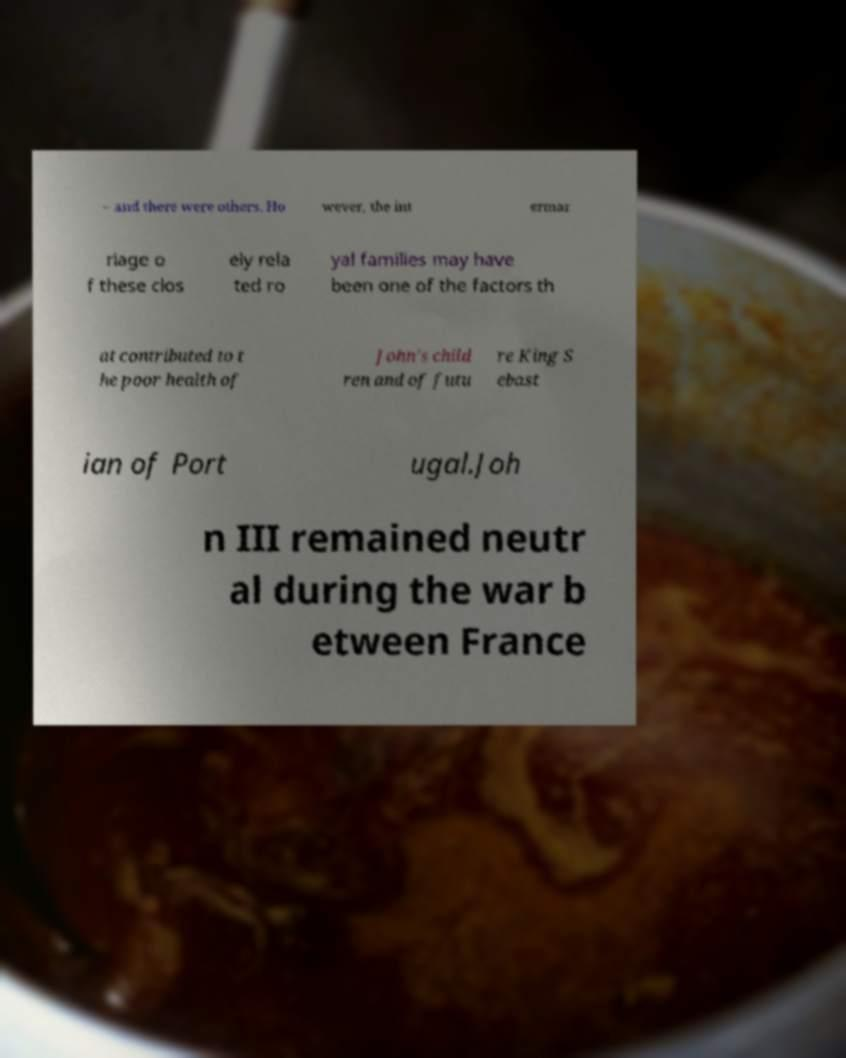Can you read and provide the text displayed in the image?This photo seems to have some interesting text. Can you extract and type it out for me? – and there were others. Ho wever, the int ermar riage o f these clos ely rela ted ro yal families may have been one of the factors th at contributed to t he poor health of John's child ren and of futu re King S ebast ian of Port ugal.Joh n III remained neutr al during the war b etween France 